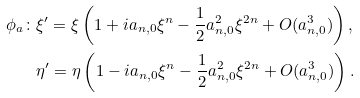<formula> <loc_0><loc_0><loc_500><loc_500>\phi _ { a } \colon & \xi ^ { \prime } = \xi \left ( 1 + i a _ { n , 0 } \xi ^ { n } - \frac { 1 } { 2 } a _ { n , 0 } ^ { 2 } \xi ^ { 2 n } + O ( a _ { n , 0 } ^ { 3 } ) \right ) , \\ & \eta ^ { \prime } = \eta \left ( 1 - i a _ { n , 0 } \xi ^ { n } - \frac { 1 } { 2 } a _ { n , 0 } ^ { 2 } \xi ^ { 2 n } + O ( a _ { n , 0 } ^ { 3 } ) \right ) .</formula> 